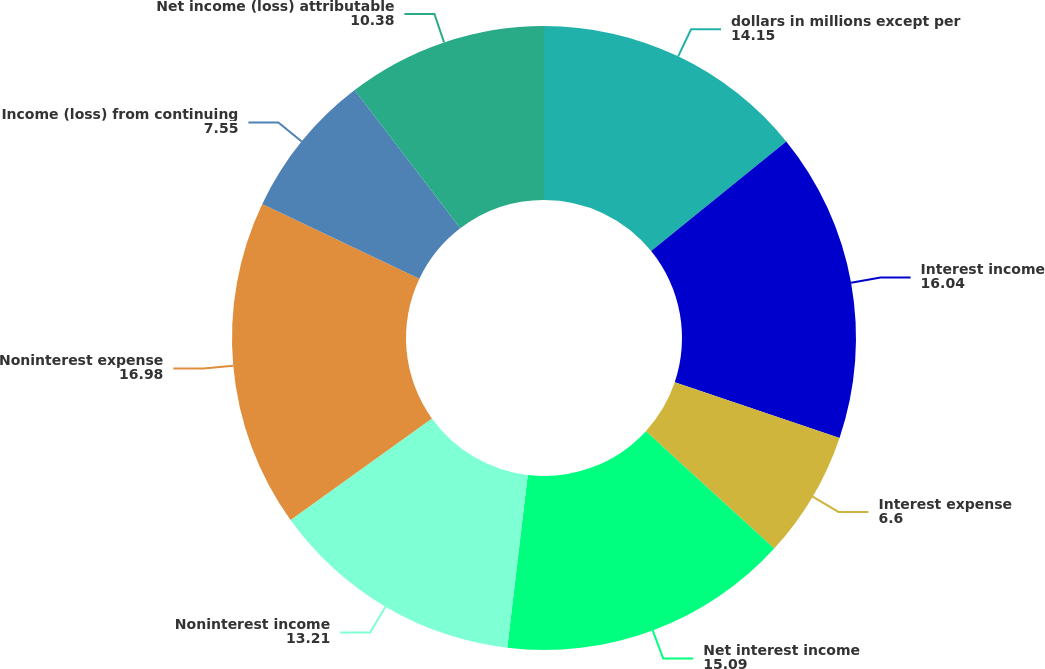<chart> <loc_0><loc_0><loc_500><loc_500><pie_chart><fcel>dollars in millions except per<fcel>Interest income<fcel>Interest expense<fcel>Net interest income<fcel>Noninterest income<fcel>Noninterest expense<fcel>Income (loss) from continuing<fcel>Net income (loss) attributable<nl><fcel>14.15%<fcel>16.04%<fcel>6.6%<fcel>15.09%<fcel>13.21%<fcel>16.98%<fcel>7.55%<fcel>10.38%<nl></chart> 